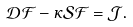Convert formula to latex. <formula><loc_0><loc_0><loc_500><loc_500>\mathcal { D } \mathcal { F } - \kappa \mathcal { S } \mathcal { F } = \mathcal { J } .</formula> 